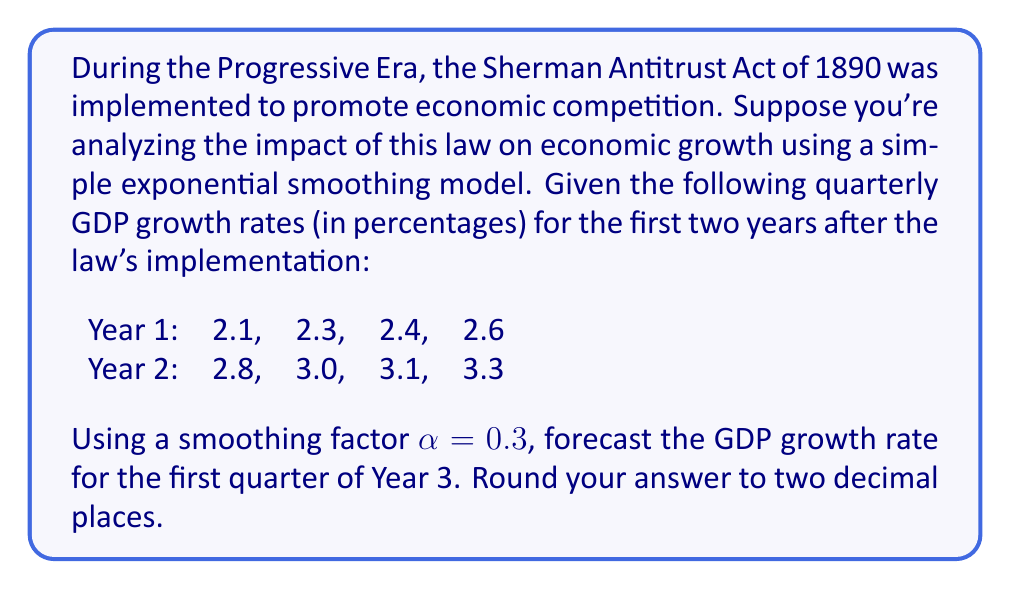Can you solve this math problem? To solve this problem, we'll use the simple exponential smoothing model, which is appropriate for time series data without clear trends or seasonality. The formula for this model is:

$$F_{t+1} = \alpha Y_t + (1-\alpha)F_t$$

Where:
$F_{t+1}$ is the forecast for the next period
$\alpha$ is the smoothing factor (0.3 in this case)
$Y_t$ is the actual value at time t
$F_t$ is the forecast for the current period

Let's calculate the forecasts step by step:

1. Initial forecast (F1): We'll use the first actual value as our initial forecast.
   $F_1 = 2.1$

2. For Q2 of Year 1:
   $F_2 = 0.3 * 2.1 + 0.7 * 2.1 = 2.1$

3. For Q3 of Year 1:
   $F_3 = 0.3 * 2.3 + 0.7 * 2.1 = 2.16$

4. For Q4 of Year 1:
   $F_4 = 0.3 * 2.4 + 0.7 * 2.16 = 2.232$

5. For Q1 of Year 2:
   $F_5 = 0.3 * 2.6 + 0.7 * 2.232 = 2.3424$

6. For Q2 of Year 2:
   $F_6 = 0.3 * 2.8 + 0.7 * 2.3424 = 2.48968$

7. For Q3 of Year 2:
   $F_7 = 0.3 * 3.0 + 0.7 * 2.48968 = 2.642776$

8. For Q4 of Year 2:
   $F_8 = 0.3 * 3.1 + 0.7 * 2.642776 = 2.7799432$

9. Finally, for Q1 of Year 3:
   $F_9 = 0.3 * 3.3 + 0.7 * 2.7799432 = 2.9459602$

Rounding to two decimal places, we get 2.95.
Answer: 2.95 